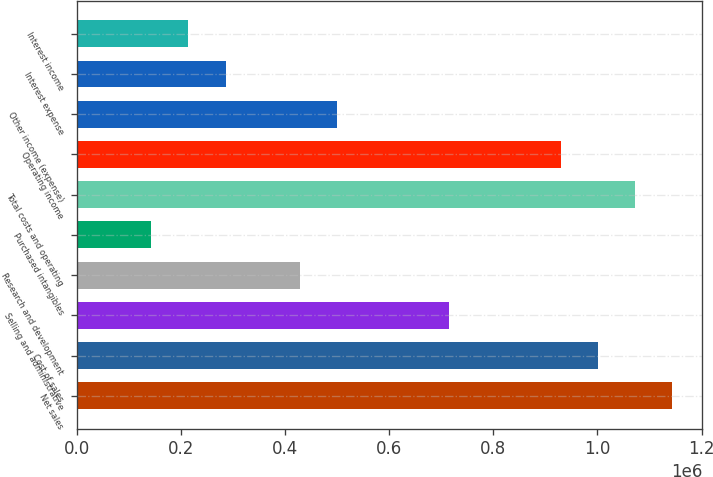<chart> <loc_0><loc_0><loc_500><loc_500><bar_chart><fcel>Net sales<fcel>Cost of sales<fcel>Selling and administrative<fcel>Research and development<fcel>Purchased intangibles<fcel>Total costs and operating<fcel>Operating income<fcel>Other income (expense)<fcel>Interest expense<fcel>Interest income<nl><fcel>1.14403e+06<fcel>1.00103e+06<fcel>715019<fcel>429012<fcel>143006<fcel>1.07253e+06<fcel>929524<fcel>500514<fcel>286009<fcel>214507<nl></chart> 